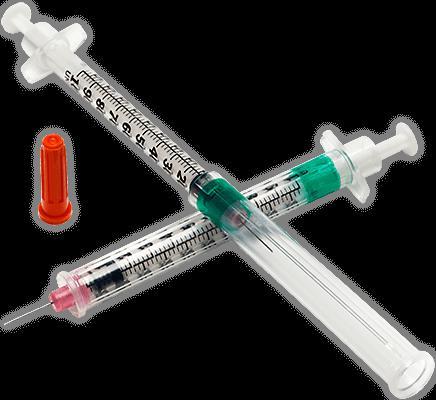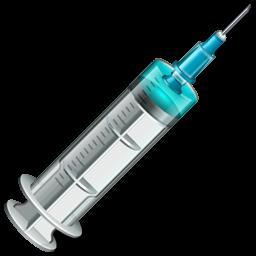The first image is the image on the left, the second image is the image on the right. Considering the images on both sides, is "Each image shows only a single syringe." valid? Answer yes or no. No. The first image is the image on the left, the second image is the image on the right. Considering the images on both sides, is "Each image shows exactly one syringe, displayed at an angle." valid? Answer yes or no. No. 